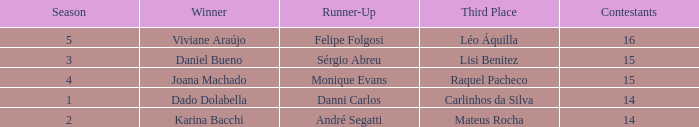In what season was the winner Dado Dolabella? 1.0. 